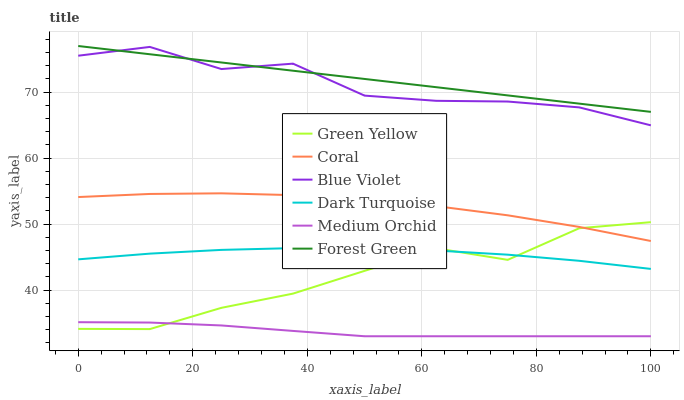Does Medium Orchid have the minimum area under the curve?
Answer yes or no. Yes. Does Forest Green have the maximum area under the curve?
Answer yes or no. Yes. Does Coral have the minimum area under the curve?
Answer yes or no. No. Does Coral have the maximum area under the curve?
Answer yes or no. No. Is Forest Green the smoothest?
Answer yes or no. Yes. Is Blue Violet the roughest?
Answer yes or no. Yes. Is Coral the smoothest?
Answer yes or no. No. Is Coral the roughest?
Answer yes or no. No. Does Medium Orchid have the lowest value?
Answer yes or no. Yes. Does Coral have the lowest value?
Answer yes or no. No. Does Forest Green have the highest value?
Answer yes or no. Yes. Does Coral have the highest value?
Answer yes or no. No. Is Coral less than Blue Violet?
Answer yes or no. Yes. Is Forest Green greater than Green Yellow?
Answer yes or no. Yes. Does Blue Violet intersect Forest Green?
Answer yes or no. Yes. Is Blue Violet less than Forest Green?
Answer yes or no. No. Is Blue Violet greater than Forest Green?
Answer yes or no. No. Does Coral intersect Blue Violet?
Answer yes or no. No. 